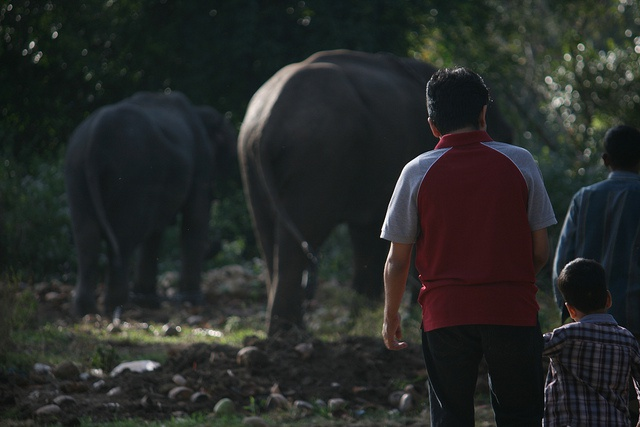Describe the objects in this image and their specific colors. I can see people in black, maroon, and gray tones, elephant in black, gray, darkgray, and darkgreen tones, elephant in black tones, people in black, gray, and maroon tones, and people in black, gray, navy, and blue tones in this image. 